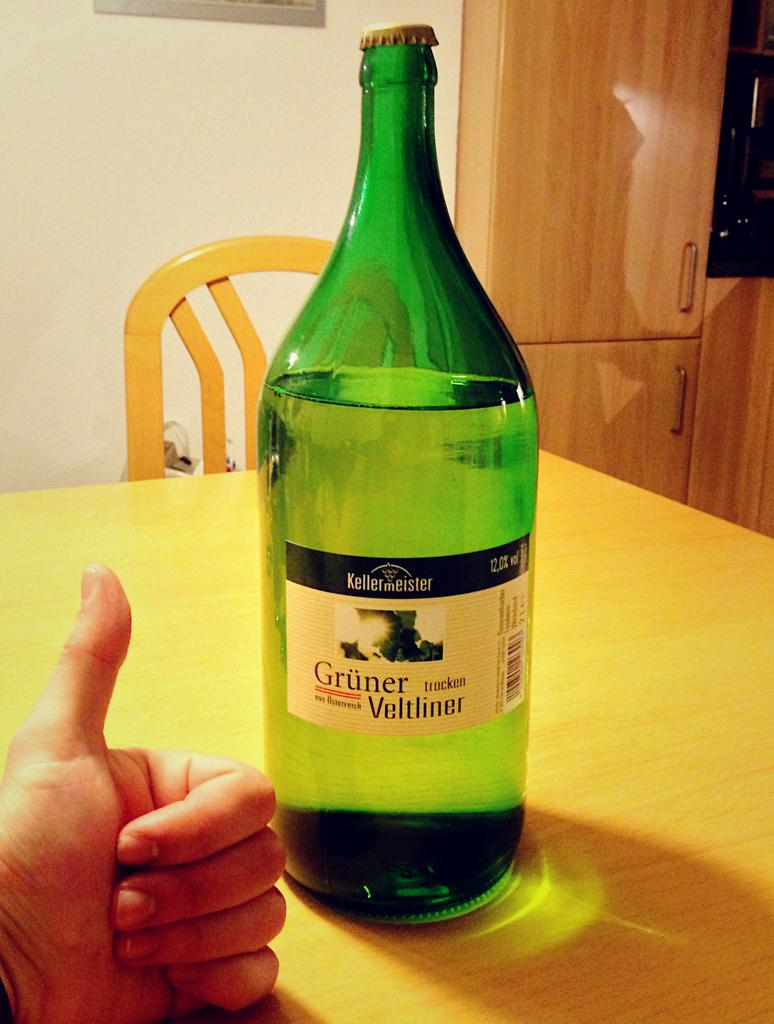<image>
Provide a brief description of the given image. Bottle of alcohol with a label which says "Gruner Veltliner" on it. 